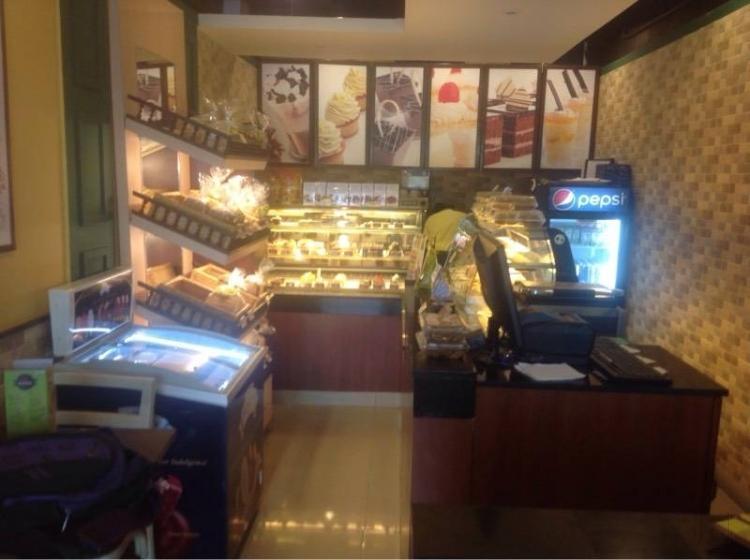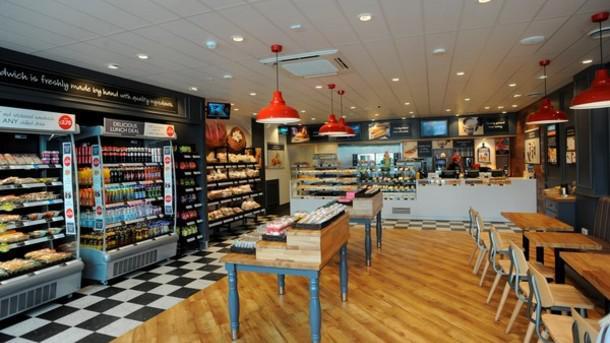The first image is the image on the left, the second image is the image on the right. Given the left and right images, does the statement "The interior of a shop has a row of suspended white lights over a pale painted counter with glass display case on top." hold true? Answer yes or no. No. The first image is the image on the left, the second image is the image on the right. Examine the images to the left and right. Is the description "There are tables and chairs for dining in at least one of the images, but there are no people." accurate? Answer yes or no. Yes. 